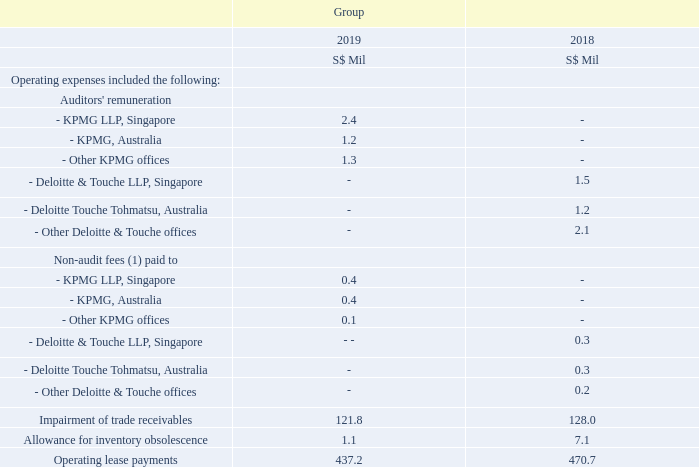5.5 Other Operating Expense Items
Note: (1) The non-audit fees for the current financial year ended 31 March 2019 included S$0.4 million and S$0.2million paid to KPMG LLP, Singapore and KPMG, Australia in respect of tax services, certification and review for regulatory purposes. In the previous financial year, the non-audit fees included S$0.2 million and S$0.3 million paid to Deloitte & Touche LLP, Singapore, and Deloitte Touche Tohmatsu, Australia, respectively in respect of tax services, certification and review for regulatory purposes.
The Audit Committee had undertaken a review of the non-audit services provided by the auditors, KPMG LLP, and in the opinion of the Audit Committee, these services did not affect the independence of the auditors. The Audit Committee had undertaken a review of the non-audit services provided by the auditors, KPMG LLP, and in the opinion of the Audit Committee, these services did not affect the independence of the auditors.
What is the key focus of note 5.5? Other operating expense items. Does the non-audit services provided by KPMG LLP affect their independence? These services did not affect the independence of the auditors. What services do the non-audit fees pertain to? Tax services, certification and review for regulatory purposes. How many categories of operating expenses are there? Auditors' remuneration## Non-audit fees## Impairment of trade receivables## Allowance for inventory obsolescence## Operating lease payments
Answer: 5. In which year was there a higher total audit fee paid? 2.4 + 1.2 + 1.3 = 4.9 > 1.5 + 1.2 + 2.1 = 4.8
Answer: 2019. What is the average impairment of trade receivables across the 2 years?
Answer scale should be: million. (128 + 121.8)/2
Answer: 124.9. 